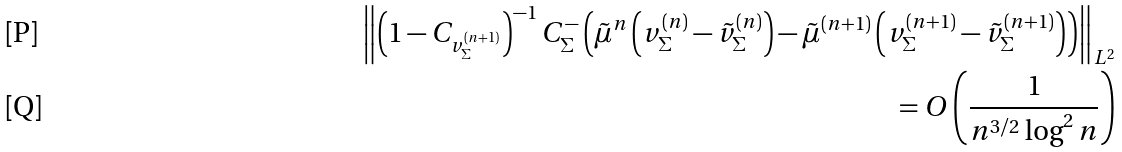<formula> <loc_0><loc_0><loc_500><loc_500>\left \| \left ( 1 - C _ { v ^ { ( n + 1 ) } _ { \Sigma } } \right ) ^ { - 1 } C _ { \Sigma } ^ { - } \left ( \tilde { \mu } ^ { n } \left ( v _ { \Sigma } ^ { ( n ) } - \tilde { v } _ { \Sigma } ^ { ( n ) } \right ) - \tilde { \mu } ^ { ( n + 1 ) } \left ( v _ { \Sigma } ^ { ( n + 1 ) } - \tilde { v } _ { \Sigma } ^ { ( n + 1 ) } \right ) \right ) \right \| _ { L ^ { 2 } } \\ = O \left ( \frac { 1 } { n ^ { 3 / 2 } \log ^ { 2 } n } \right )</formula> 